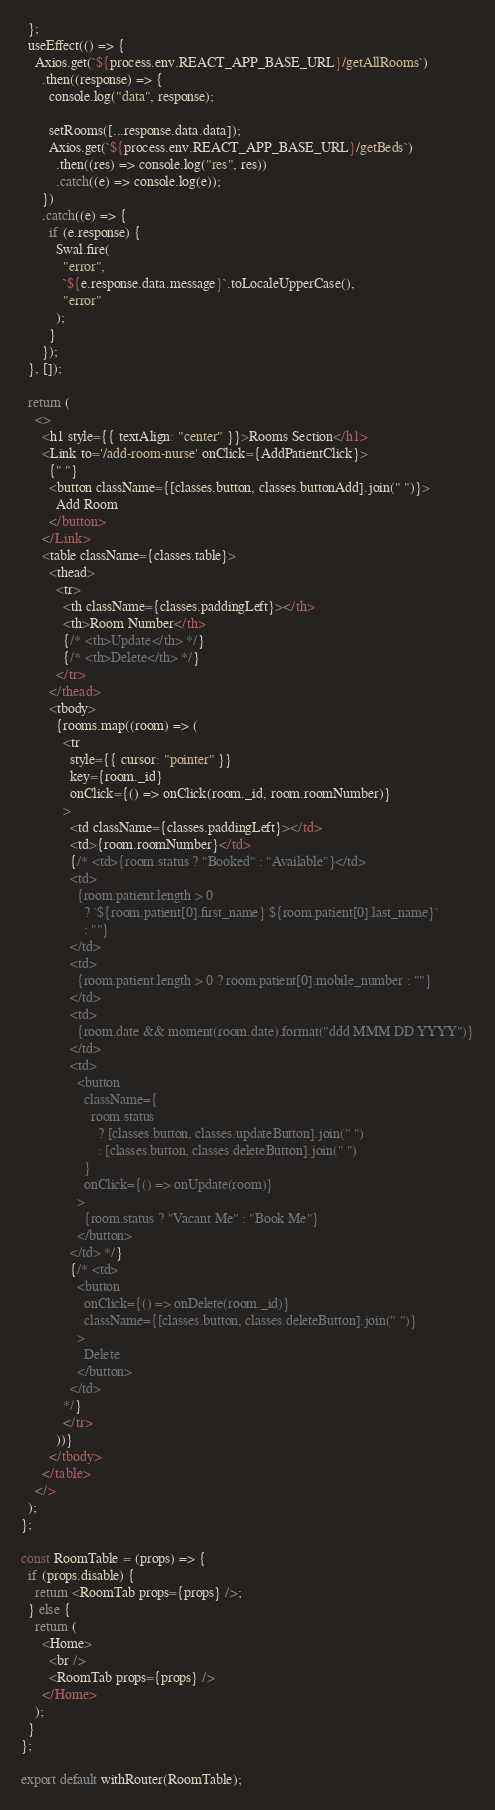<code> <loc_0><loc_0><loc_500><loc_500><_JavaScript_>  };
  useEffect(() => {
    Axios.get(`${process.env.REACT_APP_BASE_URL}/getAllRooms`)
      .then((response) => {
        console.log("data", response);

        setRooms([...response.data.data]);
        Axios.get(`${process.env.REACT_APP_BASE_URL}/getBeds`)
          .then((res) => console.log("res", res))
          .catch((e) => console.log(e));
      })
      .catch((e) => {
        if (e.response) {
          Swal.fire(
            "error",
            `${e.response.data.message}`.toLocaleUpperCase(),
            "error"
          );
        }
      });
  }, []);

  return (
    <>
      <h1 style={{ textAlign: "center" }}>Rooms Section</h1>
      <Link to='/add-room-nurse' onClick={AddPatientClick}>
        {" "}
        <button className={[classes.button, classes.buttonAdd].join(" ")}>
          Add Room
        </button>
      </Link>
      <table className={classes.table}>
        <thead>
          <tr>
            <th className={classes.paddingLeft}></th>
            <th>Room Number</th>
            {/* <th>Update</th> */}
            {/* <th>Delete</th> */}
          </tr>
        </thead>
        <tbody>
          {rooms.map((room) => (
            <tr
              style={{ cursor: "pointer" }}
              key={room._id}
              onClick={() => onClick(room._id, room.roomNumber)}
            >
              <td className={classes.paddingLeft}></td>
              <td>{room.roomNumber}</td>
              {/* <td>{room.status ? "Booked" : "Available"}</td>
              <td>
                {room.patient.length > 0
                  ? `${room.patient[0].first_name} ${room.patient[0].last_name}`
                  : ""}
              </td>
              <td>
                {room.patient.length > 0 ? room.patient[0].mobile_number : ""}
              </td>
              <td>
                {room.date && moment(room.date).format("ddd MMM DD YYYY")}
              </td>
              <td>
                <button
                  className={
                    room.status
                      ? [classes.button, classes.updateButton].join(" ")
                      : [classes.button, classes.deleteButton].join(" ")
                  }
                  onClick={() => onUpdate(room)}
                >
                  {room.status ? "Vacant Me" : "Book Me"}
                </button>
              </td> */}
              {/* <td>
                <button
                  onClick={() => onDelete(room._id)}
                  className={[classes.button, classes.deleteButton].join(" ")}
                >
                  Delete
                </button>
              </td>
            */}
            </tr>
          ))}
        </tbody>
      </table>
    </>
  );
};

const RoomTable = (props) => {
  if (props.disable) {
    return <RoomTab props={props} />;
  } else {
    return (
      <Home>
        <br />
        <RoomTab props={props} />
      </Home>
    );
  }
};

export default withRouter(RoomTable);
</code> 